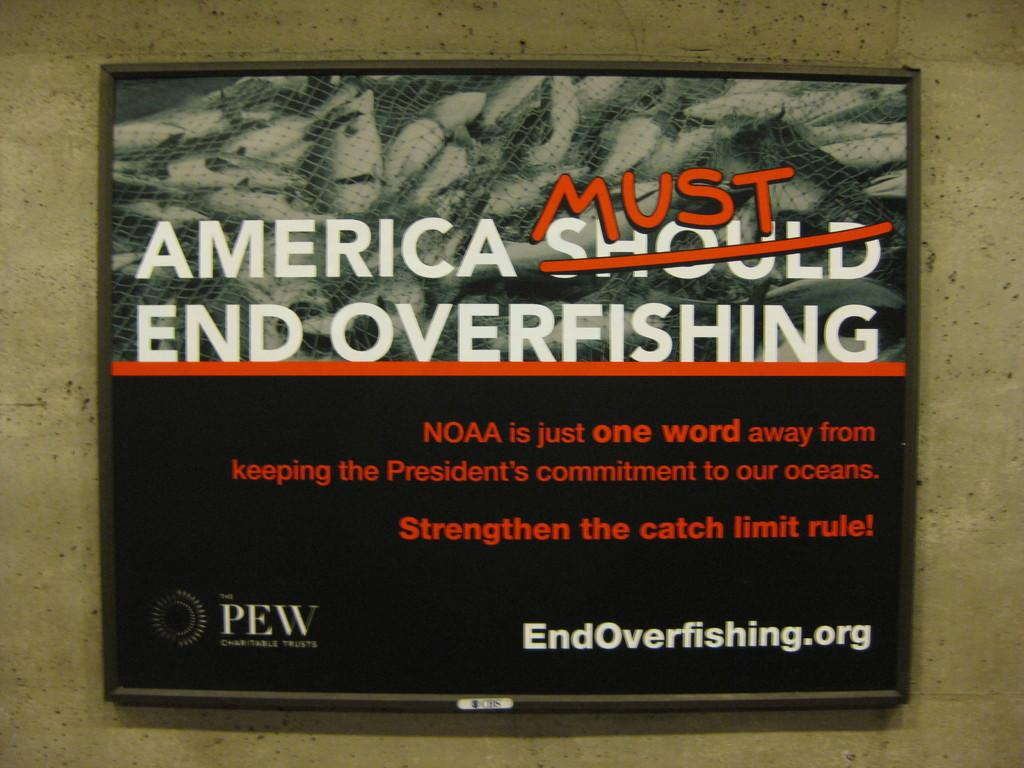<image>
Share a concise interpretation of the image provided. Sign on a wall that says "America Must end Overfishing". 